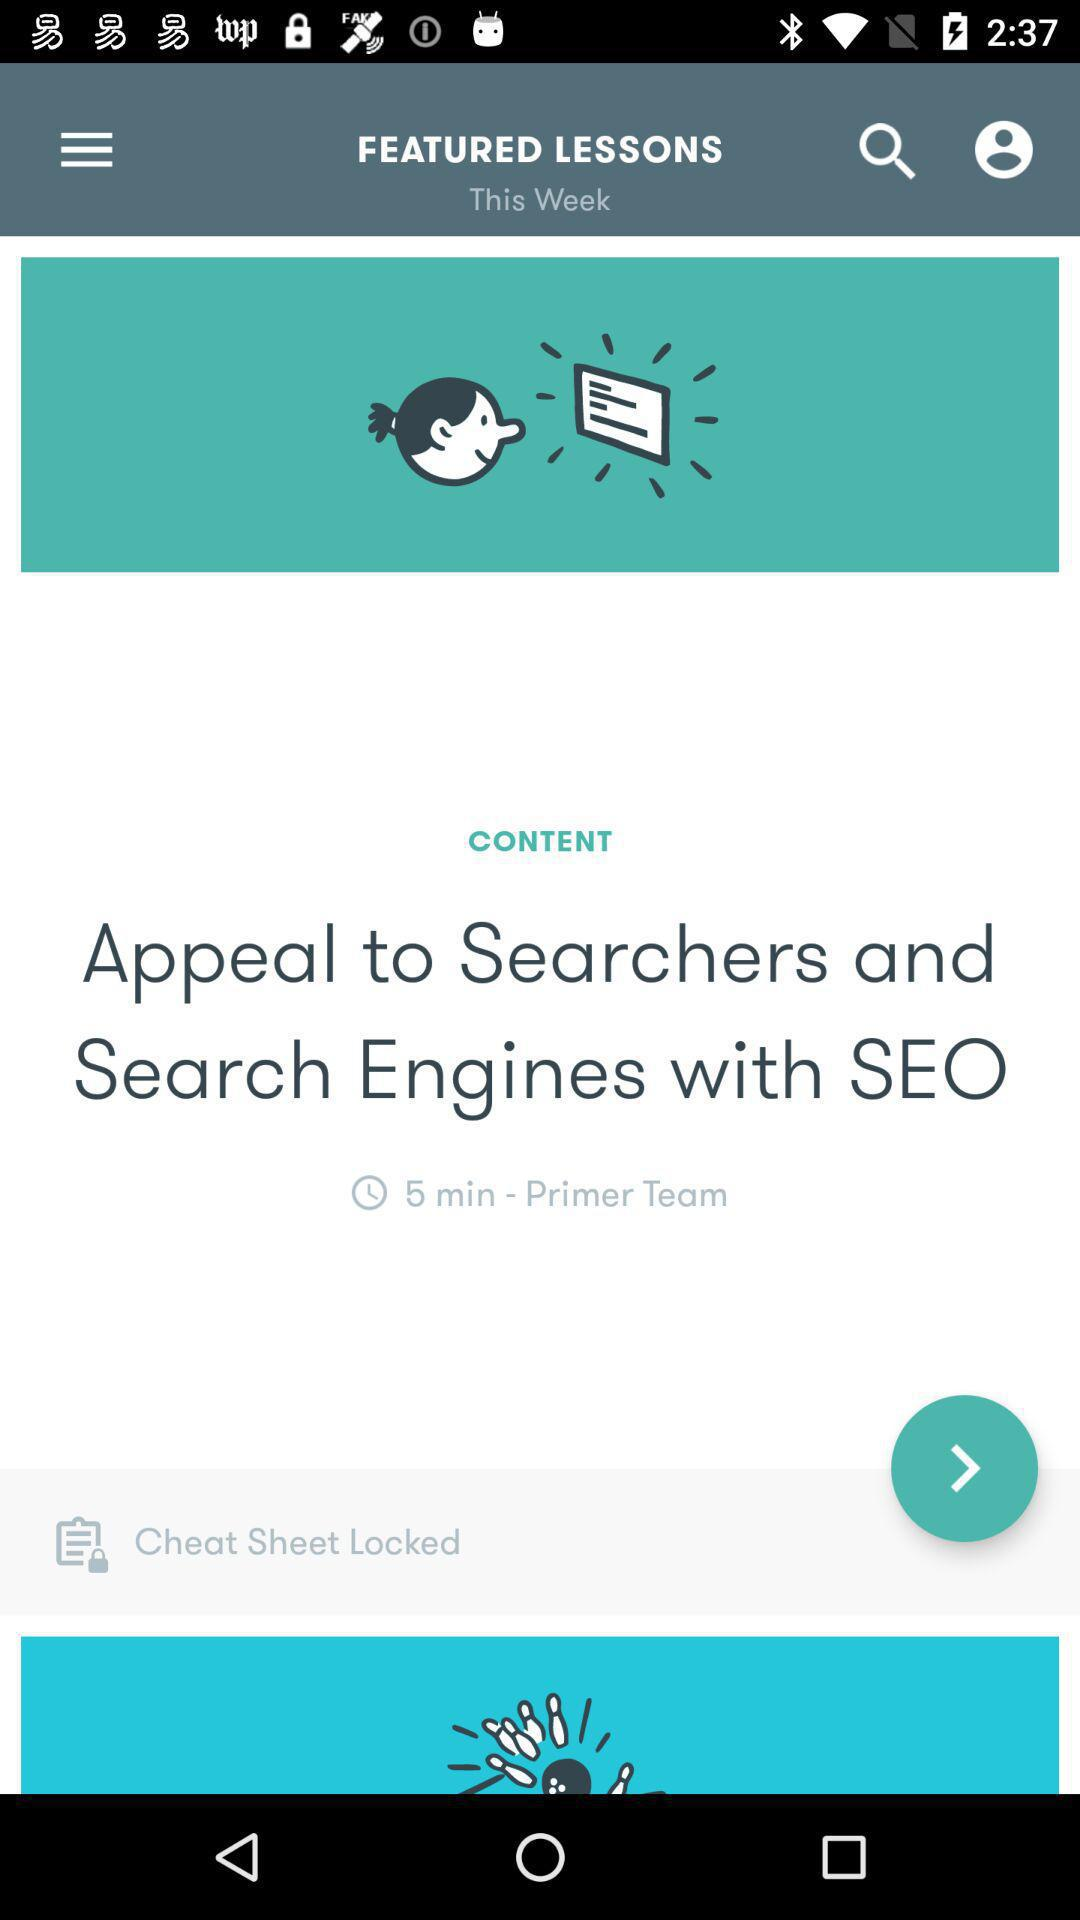What is the time duration? The time duration is 5 minutes. 